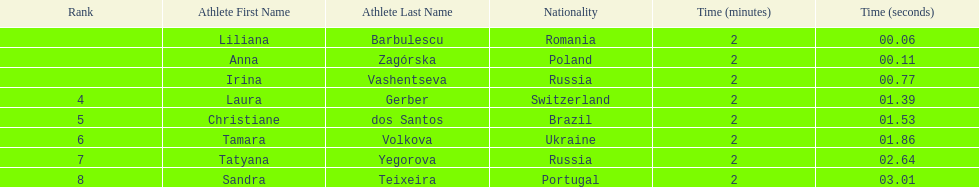What is the name of the top finalist of this semifinals heat? Liliana Barbulescu. 